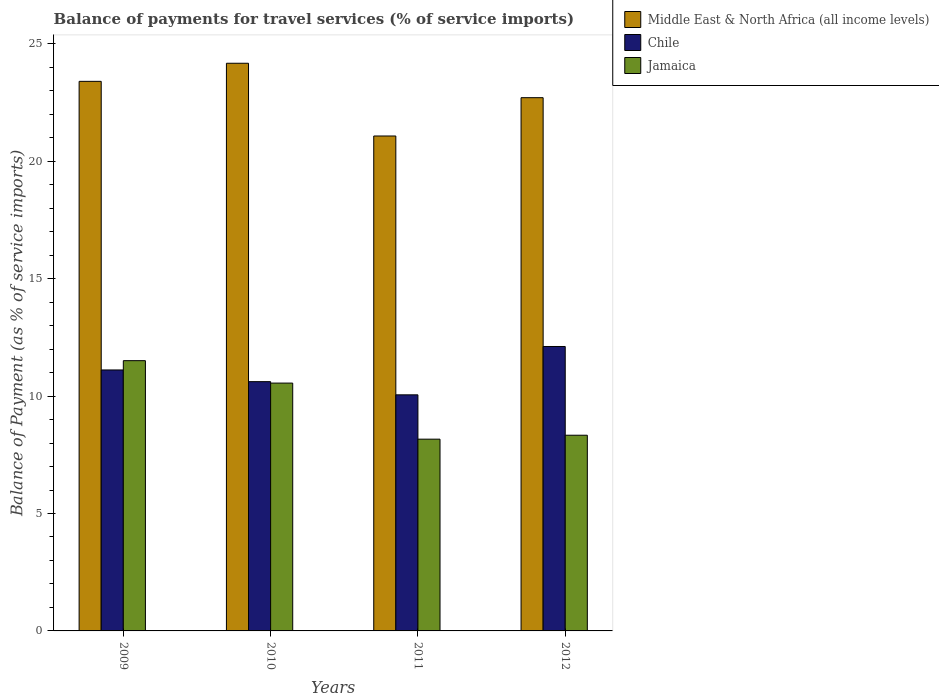How many groups of bars are there?
Keep it short and to the point. 4. Are the number of bars per tick equal to the number of legend labels?
Keep it short and to the point. Yes. What is the label of the 1st group of bars from the left?
Ensure brevity in your answer.  2009. In how many cases, is the number of bars for a given year not equal to the number of legend labels?
Your answer should be compact. 0. What is the balance of payments for travel services in Middle East & North Africa (all income levels) in 2010?
Make the answer very short. 24.17. Across all years, what is the maximum balance of payments for travel services in Middle East & North Africa (all income levels)?
Ensure brevity in your answer.  24.17. Across all years, what is the minimum balance of payments for travel services in Jamaica?
Offer a very short reply. 8.17. In which year was the balance of payments for travel services in Jamaica minimum?
Provide a succinct answer. 2011. What is the total balance of payments for travel services in Jamaica in the graph?
Give a very brief answer. 38.56. What is the difference between the balance of payments for travel services in Jamaica in 2009 and that in 2010?
Offer a very short reply. 0.96. What is the difference between the balance of payments for travel services in Middle East & North Africa (all income levels) in 2010 and the balance of payments for travel services in Jamaica in 2009?
Provide a short and direct response. 12.66. What is the average balance of payments for travel services in Chile per year?
Offer a very short reply. 10.97. In the year 2010, what is the difference between the balance of payments for travel services in Chile and balance of payments for travel services in Middle East & North Africa (all income levels)?
Ensure brevity in your answer.  -13.56. What is the ratio of the balance of payments for travel services in Middle East & North Africa (all income levels) in 2010 to that in 2011?
Your answer should be compact. 1.15. Is the balance of payments for travel services in Jamaica in 2011 less than that in 2012?
Your answer should be compact. Yes. What is the difference between the highest and the second highest balance of payments for travel services in Chile?
Provide a short and direct response. 1. What is the difference between the highest and the lowest balance of payments for travel services in Jamaica?
Offer a terse response. 3.34. Is the sum of the balance of payments for travel services in Chile in 2010 and 2011 greater than the maximum balance of payments for travel services in Jamaica across all years?
Your response must be concise. Yes. What does the 3rd bar from the left in 2012 represents?
Offer a terse response. Jamaica. Are all the bars in the graph horizontal?
Give a very brief answer. No. How many years are there in the graph?
Your answer should be very brief. 4. What is the difference between two consecutive major ticks on the Y-axis?
Make the answer very short. 5. Are the values on the major ticks of Y-axis written in scientific E-notation?
Your response must be concise. No. Does the graph contain grids?
Your answer should be very brief. No. How many legend labels are there?
Make the answer very short. 3. What is the title of the graph?
Keep it short and to the point. Balance of payments for travel services (% of service imports). What is the label or title of the Y-axis?
Your answer should be compact. Balance of Payment (as % of service imports). What is the Balance of Payment (as % of service imports) of Middle East & North Africa (all income levels) in 2009?
Offer a terse response. 23.4. What is the Balance of Payment (as % of service imports) in Chile in 2009?
Keep it short and to the point. 11.11. What is the Balance of Payment (as % of service imports) of Jamaica in 2009?
Ensure brevity in your answer.  11.51. What is the Balance of Payment (as % of service imports) in Middle East & North Africa (all income levels) in 2010?
Your response must be concise. 24.17. What is the Balance of Payment (as % of service imports) in Chile in 2010?
Provide a succinct answer. 10.61. What is the Balance of Payment (as % of service imports) of Jamaica in 2010?
Provide a short and direct response. 10.55. What is the Balance of Payment (as % of service imports) in Middle East & North Africa (all income levels) in 2011?
Provide a succinct answer. 21.08. What is the Balance of Payment (as % of service imports) of Chile in 2011?
Provide a short and direct response. 10.05. What is the Balance of Payment (as % of service imports) in Jamaica in 2011?
Your answer should be very brief. 8.17. What is the Balance of Payment (as % of service imports) of Middle East & North Africa (all income levels) in 2012?
Provide a short and direct response. 22.71. What is the Balance of Payment (as % of service imports) in Chile in 2012?
Your answer should be very brief. 12.11. What is the Balance of Payment (as % of service imports) of Jamaica in 2012?
Your response must be concise. 8.33. Across all years, what is the maximum Balance of Payment (as % of service imports) of Middle East & North Africa (all income levels)?
Provide a short and direct response. 24.17. Across all years, what is the maximum Balance of Payment (as % of service imports) of Chile?
Make the answer very short. 12.11. Across all years, what is the maximum Balance of Payment (as % of service imports) in Jamaica?
Offer a very short reply. 11.51. Across all years, what is the minimum Balance of Payment (as % of service imports) of Middle East & North Africa (all income levels)?
Your answer should be very brief. 21.08. Across all years, what is the minimum Balance of Payment (as % of service imports) of Chile?
Provide a succinct answer. 10.05. Across all years, what is the minimum Balance of Payment (as % of service imports) of Jamaica?
Ensure brevity in your answer.  8.17. What is the total Balance of Payment (as % of service imports) in Middle East & North Africa (all income levels) in the graph?
Make the answer very short. 91.36. What is the total Balance of Payment (as % of service imports) in Chile in the graph?
Keep it short and to the point. 43.89. What is the total Balance of Payment (as % of service imports) of Jamaica in the graph?
Your answer should be compact. 38.56. What is the difference between the Balance of Payment (as % of service imports) in Middle East & North Africa (all income levels) in 2009 and that in 2010?
Provide a succinct answer. -0.77. What is the difference between the Balance of Payment (as % of service imports) in Chile in 2009 and that in 2010?
Give a very brief answer. 0.5. What is the difference between the Balance of Payment (as % of service imports) in Jamaica in 2009 and that in 2010?
Offer a very short reply. 0.96. What is the difference between the Balance of Payment (as % of service imports) in Middle East & North Africa (all income levels) in 2009 and that in 2011?
Ensure brevity in your answer.  2.33. What is the difference between the Balance of Payment (as % of service imports) of Chile in 2009 and that in 2011?
Your answer should be compact. 1.06. What is the difference between the Balance of Payment (as % of service imports) of Jamaica in 2009 and that in 2011?
Make the answer very short. 3.34. What is the difference between the Balance of Payment (as % of service imports) of Middle East & North Africa (all income levels) in 2009 and that in 2012?
Your answer should be compact. 0.7. What is the difference between the Balance of Payment (as % of service imports) in Chile in 2009 and that in 2012?
Ensure brevity in your answer.  -1. What is the difference between the Balance of Payment (as % of service imports) in Jamaica in 2009 and that in 2012?
Your answer should be compact. 3.18. What is the difference between the Balance of Payment (as % of service imports) of Middle East & North Africa (all income levels) in 2010 and that in 2011?
Your answer should be compact. 3.1. What is the difference between the Balance of Payment (as % of service imports) in Chile in 2010 and that in 2011?
Offer a terse response. 0.56. What is the difference between the Balance of Payment (as % of service imports) of Jamaica in 2010 and that in 2011?
Offer a terse response. 2.39. What is the difference between the Balance of Payment (as % of service imports) of Middle East & North Africa (all income levels) in 2010 and that in 2012?
Provide a succinct answer. 1.47. What is the difference between the Balance of Payment (as % of service imports) in Chile in 2010 and that in 2012?
Keep it short and to the point. -1.5. What is the difference between the Balance of Payment (as % of service imports) in Jamaica in 2010 and that in 2012?
Give a very brief answer. 2.22. What is the difference between the Balance of Payment (as % of service imports) of Middle East & North Africa (all income levels) in 2011 and that in 2012?
Your answer should be very brief. -1.63. What is the difference between the Balance of Payment (as % of service imports) in Chile in 2011 and that in 2012?
Keep it short and to the point. -2.06. What is the difference between the Balance of Payment (as % of service imports) of Jamaica in 2011 and that in 2012?
Give a very brief answer. -0.17. What is the difference between the Balance of Payment (as % of service imports) in Middle East & North Africa (all income levels) in 2009 and the Balance of Payment (as % of service imports) in Chile in 2010?
Give a very brief answer. 12.79. What is the difference between the Balance of Payment (as % of service imports) in Middle East & North Africa (all income levels) in 2009 and the Balance of Payment (as % of service imports) in Jamaica in 2010?
Keep it short and to the point. 12.85. What is the difference between the Balance of Payment (as % of service imports) of Chile in 2009 and the Balance of Payment (as % of service imports) of Jamaica in 2010?
Provide a succinct answer. 0.56. What is the difference between the Balance of Payment (as % of service imports) of Middle East & North Africa (all income levels) in 2009 and the Balance of Payment (as % of service imports) of Chile in 2011?
Your answer should be very brief. 13.35. What is the difference between the Balance of Payment (as % of service imports) in Middle East & North Africa (all income levels) in 2009 and the Balance of Payment (as % of service imports) in Jamaica in 2011?
Your response must be concise. 15.24. What is the difference between the Balance of Payment (as % of service imports) in Chile in 2009 and the Balance of Payment (as % of service imports) in Jamaica in 2011?
Offer a very short reply. 2.95. What is the difference between the Balance of Payment (as % of service imports) of Middle East & North Africa (all income levels) in 2009 and the Balance of Payment (as % of service imports) of Chile in 2012?
Provide a short and direct response. 11.29. What is the difference between the Balance of Payment (as % of service imports) of Middle East & North Africa (all income levels) in 2009 and the Balance of Payment (as % of service imports) of Jamaica in 2012?
Give a very brief answer. 15.07. What is the difference between the Balance of Payment (as % of service imports) of Chile in 2009 and the Balance of Payment (as % of service imports) of Jamaica in 2012?
Provide a succinct answer. 2.78. What is the difference between the Balance of Payment (as % of service imports) of Middle East & North Africa (all income levels) in 2010 and the Balance of Payment (as % of service imports) of Chile in 2011?
Offer a terse response. 14.12. What is the difference between the Balance of Payment (as % of service imports) of Middle East & North Africa (all income levels) in 2010 and the Balance of Payment (as % of service imports) of Jamaica in 2011?
Offer a very short reply. 16.01. What is the difference between the Balance of Payment (as % of service imports) in Chile in 2010 and the Balance of Payment (as % of service imports) in Jamaica in 2011?
Give a very brief answer. 2.45. What is the difference between the Balance of Payment (as % of service imports) in Middle East & North Africa (all income levels) in 2010 and the Balance of Payment (as % of service imports) in Chile in 2012?
Your answer should be very brief. 12.06. What is the difference between the Balance of Payment (as % of service imports) in Middle East & North Africa (all income levels) in 2010 and the Balance of Payment (as % of service imports) in Jamaica in 2012?
Give a very brief answer. 15.84. What is the difference between the Balance of Payment (as % of service imports) in Chile in 2010 and the Balance of Payment (as % of service imports) in Jamaica in 2012?
Provide a succinct answer. 2.28. What is the difference between the Balance of Payment (as % of service imports) of Middle East & North Africa (all income levels) in 2011 and the Balance of Payment (as % of service imports) of Chile in 2012?
Your answer should be very brief. 8.96. What is the difference between the Balance of Payment (as % of service imports) in Middle East & North Africa (all income levels) in 2011 and the Balance of Payment (as % of service imports) in Jamaica in 2012?
Ensure brevity in your answer.  12.74. What is the difference between the Balance of Payment (as % of service imports) in Chile in 2011 and the Balance of Payment (as % of service imports) in Jamaica in 2012?
Your answer should be very brief. 1.72. What is the average Balance of Payment (as % of service imports) in Middle East & North Africa (all income levels) per year?
Ensure brevity in your answer.  22.84. What is the average Balance of Payment (as % of service imports) in Chile per year?
Give a very brief answer. 10.97. What is the average Balance of Payment (as % of service imports) of Jamaica per year?
Ensure brevity in your answer.  9.64. In the year 2009, what is the difference between the Balance of Payment (as % of service imports) of Middle East & North Africa (all income levels) and Balance of Payment (as % of service imports) of Chile?
Your response must be concise. 12.29. In the year 2009, what is the difference between the Balance of Payment (as % of service imports) of Middle East & North Africa (all income levels) and Balance of Payment (as % of service imports) of Jamaica?
Your answer should be compact. 11.89. In the year 2009, what is the difference between the Balance of Payment (as % of service imports) of Chile and Balance of Payment (as % of service imports) of Jamaica?
Your response must be concise. -0.4. In the year 2010, what is the difference between the Balance of Payment (as % of service imports) in Middle East & North Africa (all income levels) and Balance of Payment (as % of service imports) in Chile?
Offer a very short reply. 13.56. In the year 2010, what is the difference between the Balance of Payment (as % of service imports) of Middle East & North Africa (all income levels) and Balance of Payment (as % of service imports) of Jamaica?
Keep it short and to the point. 13.62. In the year 2010, what is the difference between the Balance of Payment (as % of service imports) of Chile and Balance of Payment (as % of service imports) of Jamaica?
Offer a terse response. 0.06. In the year 2011, what is the difference between the Balance of Payment (as % of service imports) in Middle East & North Africa (all income levels) and Balance of Payment (as % of service imports) in Chile?
Provide a short and direct response. 11.02. In the year 2011, what is the difference between the Balance of Payment (as % of service imports) in Middle East & North Africa (all income levels) and Balance of Payment (as % of service imports) in Jamaica?
Your answer should be very brief. 12.91. In the year 2011, what is the difference between the Balance of Payment (as % of service imports) in Chile and Balance of Payment (as % of service imports) in Jamaica?
Keep it short and to the point. 1.89. In the year 2012, what is the difference between the Balance of Payment (as % of service imports) of Middle East & North Africa (all income levels) and Balance of Payment (as % of service imports) of Chile?
Keep it short and to the point. 10.6. In the year 2012, what is the difference between the Balance of Payment (as % of service imports) in Middle East & North Africa (all income levels) and Balance of Payment (as % of service imports) in Jamaica?
Provide a succinct answer. 14.37. In the year 2012, what is the difference between the Balance of Payment (as % of service imports) in Chile and Balance of Payment (as % of service imports) in Jamaica?
Keep it short and to the point. 3.78. What is the ratio of the Balance of Payment (as % of service imports) in Middle East & North Africa (all income levels) in 2009 to that in 2010?
Make the answer very short. 0.97. What is the ratio of the Balance of Payment (as % of service imports) in Chile in 2009 to that in 2010?
Make the answer very short. 1.05. What is the ratio of the Balance of Payment (as % of service imports) in Jamaica in 2009 to that in 2010?
Keep it short and to the point. 1.09. What is the ratio of the Balance of Payment (as % of service imports) in Middle East & North Africa (all income levels) in 2009 to that in 2011?
Make the answer very short. 1.11. What is the ratio of the Balance of Payment (as % of service imports) in Chile in 2009 to that in 2011?
Offer a terse response. 1.11. What is the ratio of the Balance of Payment (as % of service imports) in Jamaica in 2009 to that in 2011?
Offer a terse response. 1.41. What is the ratio of the Balance of Payment (as % of service imports) of Middle East & North Africa (all income levels) in 2009 to that in 2012?
Provide a succinct answer. 1.03. What is the ratio of the Balance of Payment (as % of service imports) of Chile in 2009 to that in 2012?
Provide a short and direct response. 0.92. What is the ratio of the Balance of Payment (as % of service imports) of Jamaica in 2009 to that in 2012?
Provide a succinct answer. 1.38. What is the ratio of the Balance of Payment (as % of service imports) of Middle East & North Africa (all income levels) in 2010 to that in 2011?
Your answer should be very brief. 1.15. What is the ratio of the Balance of Payment (as % of service imports) of Chile in 2010 to that in 2011?
Ensure brevity in your answer.  1.06. What is the ratio of the Balance of Payment (as % of service imports) in Jamaica in 2010 to that in 2011?
Your answer should be very brief. 1.29. What is the ratio of the Balance of Payment (as % of service imports) of Middle East & North Africa (all income levels) in 2010 to that in 2012?
Keep it short and to the point. 1.06. What is the ratio of the Balance of Payment (as % of service imports) in Chile in 2010 to that in 2012?
Your answer should be compact. 0.88. What is the ratio of the Balance of Payment (as % of service imports) of Jamaica in 2010 to that in 2012?
Keep it short and to the point. 1.27. What is the ratio of the Balance of Payment (as % of service imports) in Middle East & North Africa (all income levels) in 2011 to that in 2012?
Offer a terse response. 0.93. What is the ratio of the Balance of Payment (as % of service imports) in Chile in 2011 to that in 2012?
Make the answer very short. 0.83. What is the ratio of the Balance of Payment (as % of service imports) in Jamaica in 2011 to that in 2012?
Ensure brevity in your answer.  0.98. What is the difference between the highest and the second highest Balance of Payment (as % of service imports) in Middle East & North Africa (all income levels)?
Your answer should be compact. 0.77. What is the difference between the highest and the second highest Balance of Payment (as % of service imports) of Chile?
Provide a short and direct response. 1. What is the difference between the highest and the second highest Balance of Payment (as % of service imports) in Jamaica?
Offer a very short reply. 0.96. What is the difference between the highest and the lowest Balance of Payment (as % of service imports) in Middle East & North Africa (all income levels)?
Your response must be concise. 3.1. What is the difference between the highest and the lowest Balance of Payment (as % of service imports) in Chile?
Your answer should be compact. 2.06. What is the difference between the highest and the lowest Balance of Payment (as % of service imports) in Jamaica?
Your answer should be very brief. 3.34. 